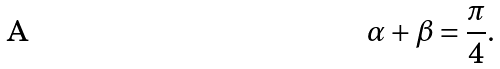<formula> <loc_0><loc_0><loc_500><loc_500>\alpha + \beta = \frac { \pi } { 4 } .</formula> 